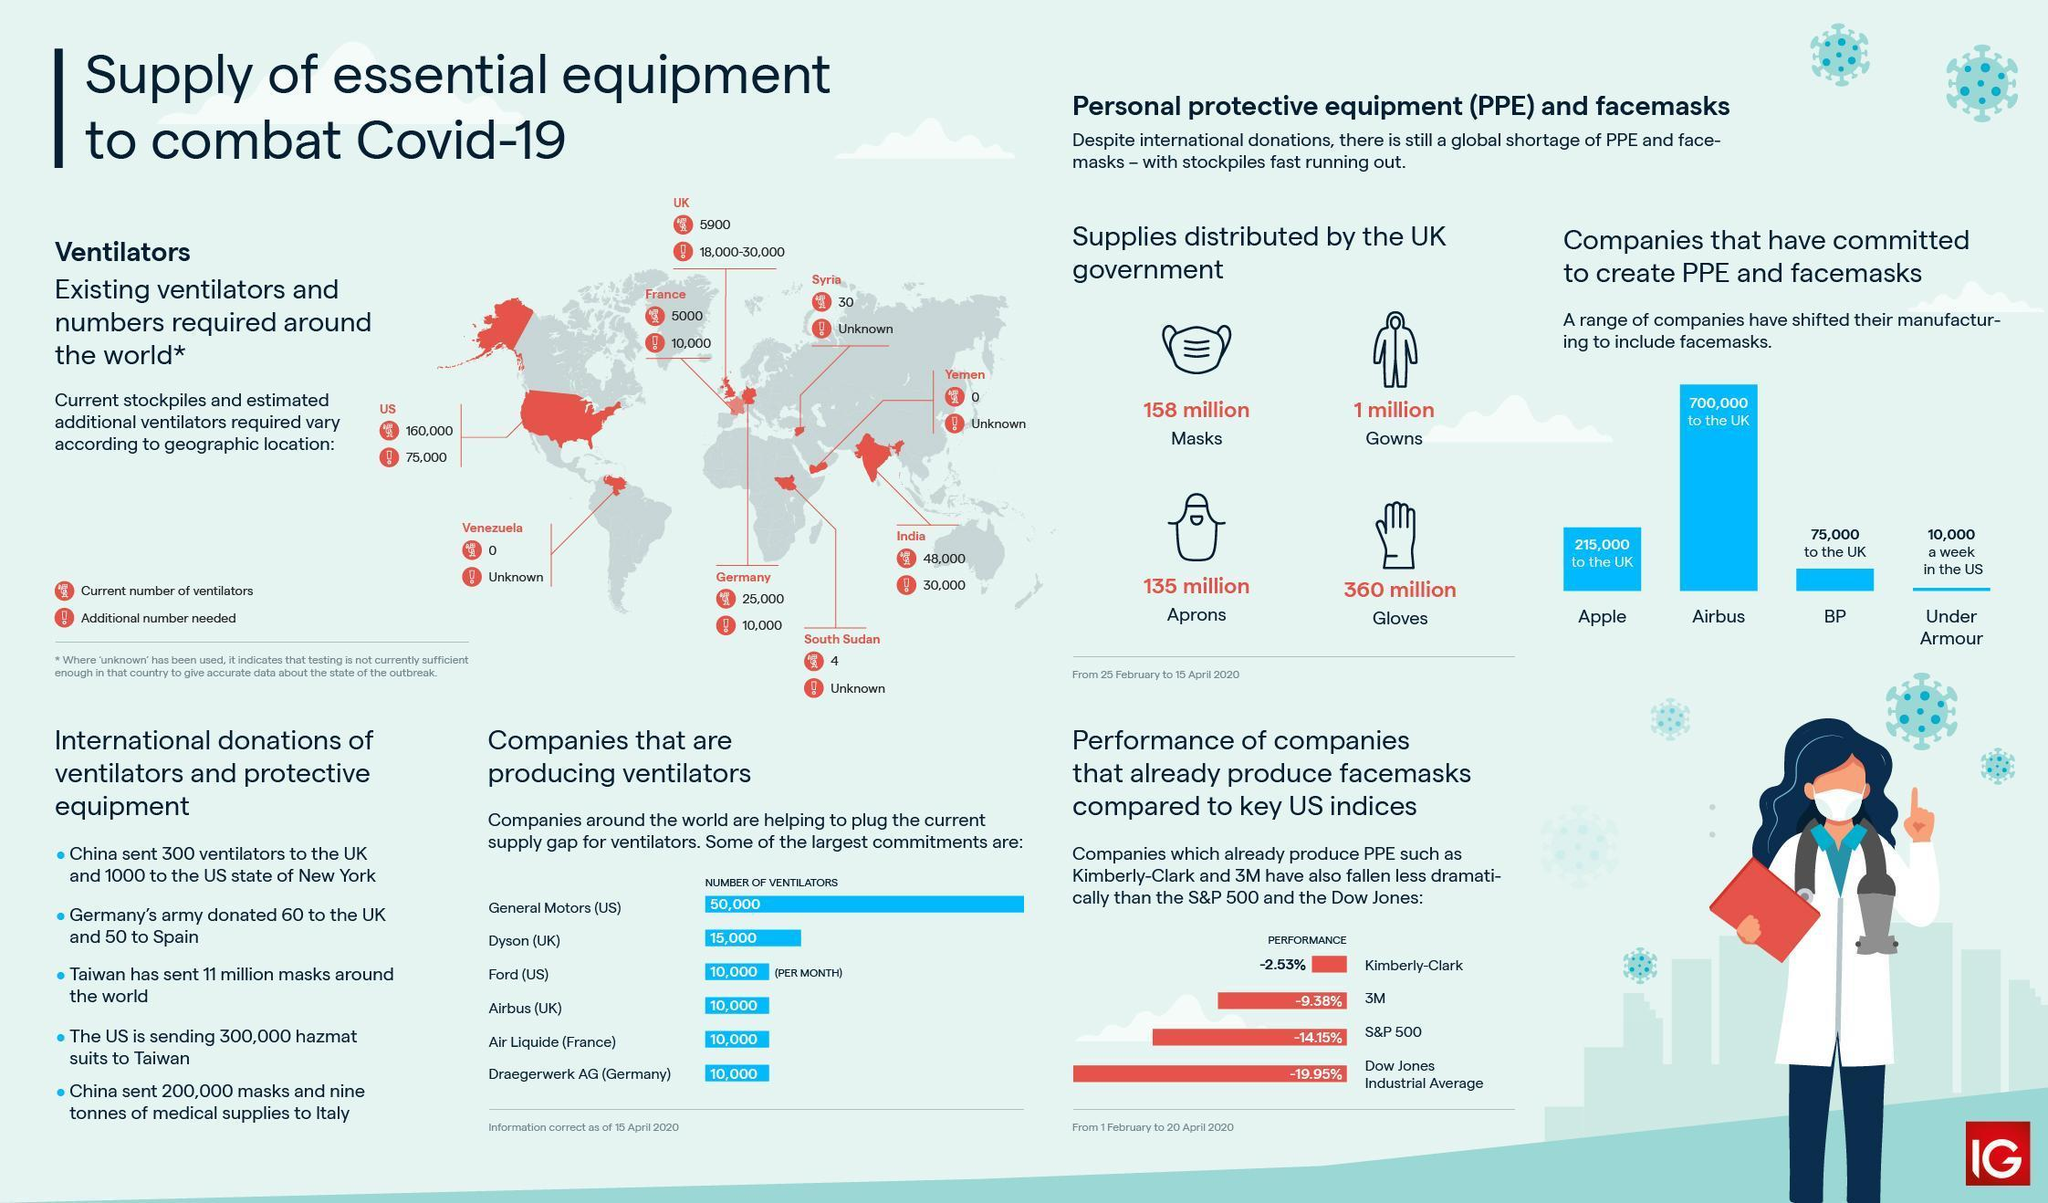How many gowns were distributed by the UK government from 25 February to 15 April 2020?
Answer the question with a short phrase. 1 million How many additional ventilators are needed in France in order to combat Covid-19? 10,000 How many additional ventilators are needed in India in order to combat Covid-19? 30,000 What is the number of ventilators produced per month by the Airbus (UK) in order to combat Covid-19 as of 15 April 2020? 10,000 How many masks were distributed by the UK government from 25 February to 15 April 2020? 158 million What is the number of ventilators produced per month by the Dyson (UK) in order to combat Covid-19 as of 15 April 2020? 15,000 How many gloves were distributed by the UK government from 25 February to 15 April 2020? 360 million How many additional ventilators are needed in the US in order to combat Covid-19? 75,000 What is the number of ventilators currently available in Germany? 25,000 What is the number of ventilators currently available in the UK? 5900 